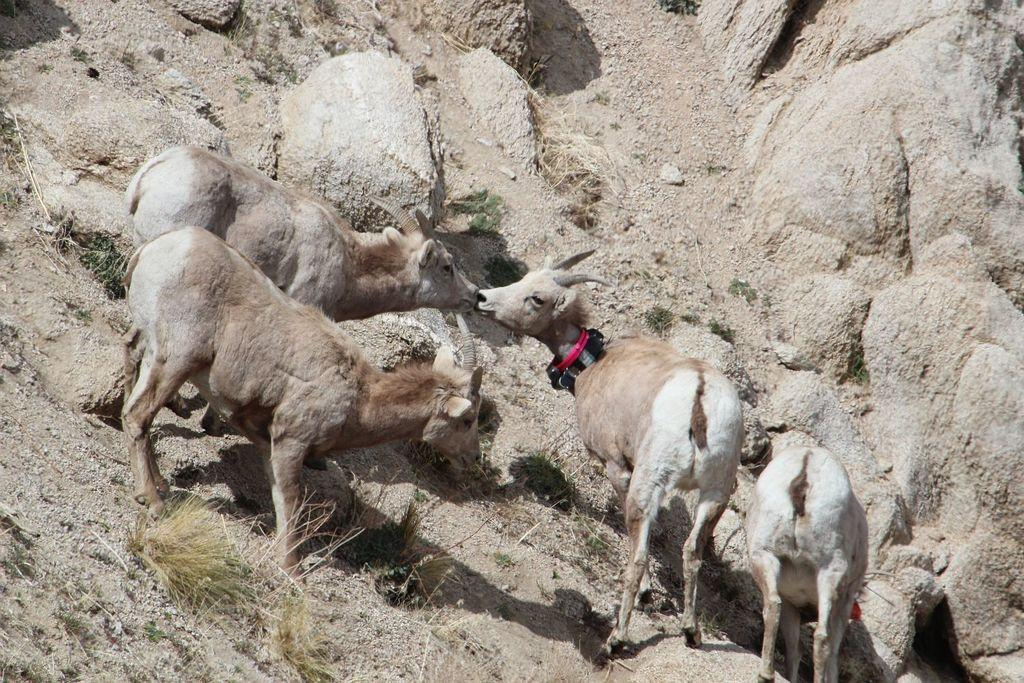What types of living organisms can be seen in the image? There are animals in the image. What is located at the bottom of the image? There are rocks at the bottom of the image. What type of bells can be heard ringing in the image? There are no bells present in the image, and therefore no sound can be heard. 